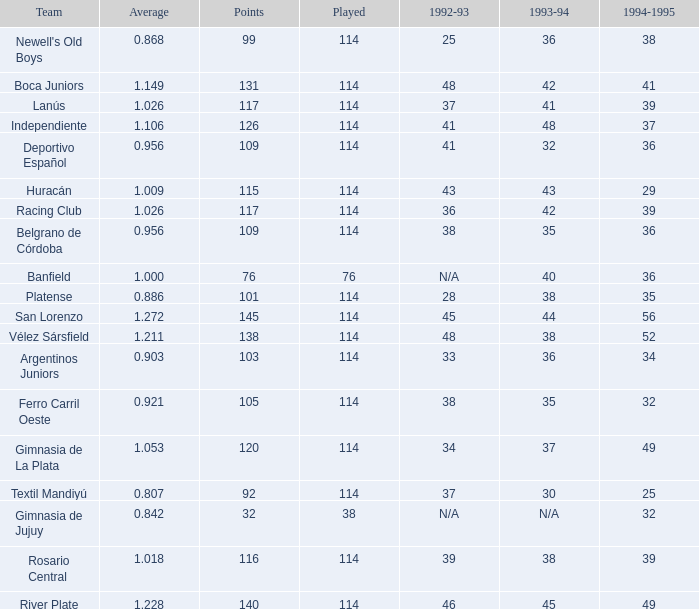Name the most played 114.0. 